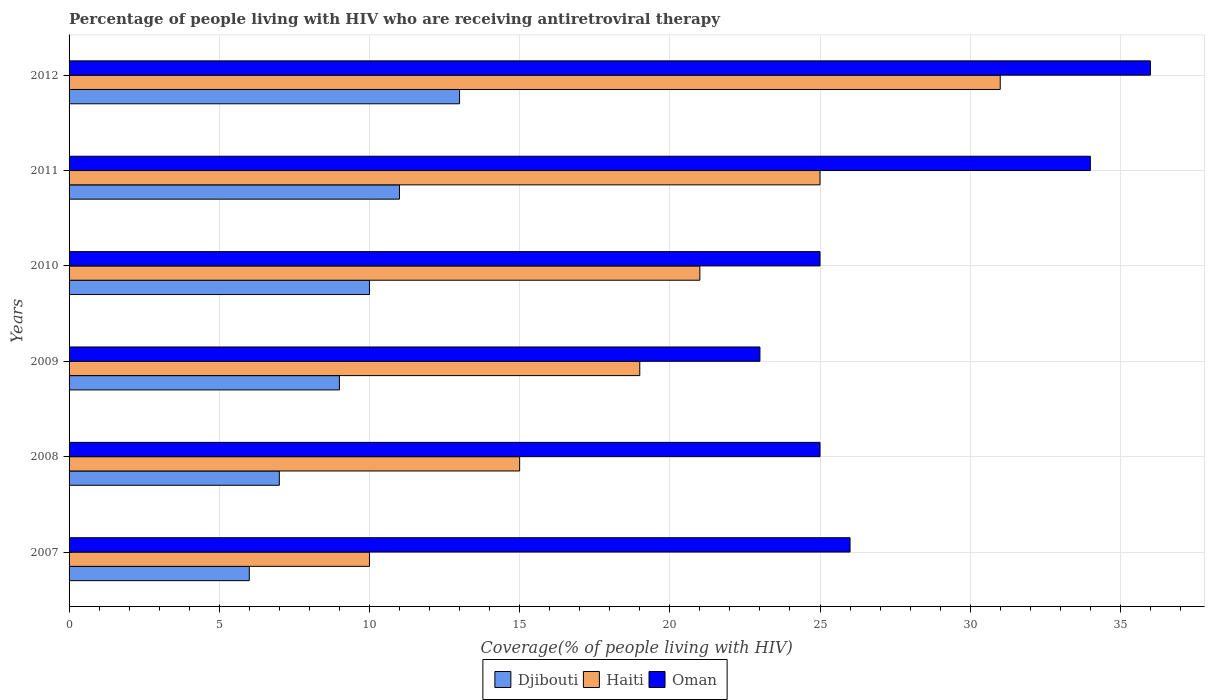How many different coloured bars are there?
Provide a short and direct response. 3. How many groups of bars are there?
Give a very brief answer. 6. Are the number of bars per tick equal to the number of legend labels?
Your answer should be compact. Yes. Are the number of bars on each tick of the Y-axis equal?
Your answer should be very brief. Yes. How many bars are there on the 6th tick from the top?
Your answer should be very brief. 3. How many bars are there on the 2nd tick from the bottom?
Ensure brevity in your answer.  3. What is the label of the 3rd group of bars from the top?
Keep it short and to the point. 2010. What is the percentage of the HIV infected people who are receiving antiretroviral therapy in Haiti in 2012?
Ensure brevity in your answer.  31. Across all years, what is the maximum percentage of the HIV infected people who are receiving antiretroviral therapy in Oman?
Give a very brief answer. 36. Across all years, what is the minimum percentage of the HIV infected people who are receiving antiretroviral therapy in Oman?
Your answer should be compact. 23. In which year was the percentage of the HIV infected people who are receiving antiretroviral therapy in Oman minimum?
Provide a short and direct response. 2009. What is the total percentage of the HIV infected people who are receiving antiretroviral therapy in Djibouti in the graph?
Your answer should be very brief. 56. What is the difference between the percentage of the HIV infected people who are receiving antiretroviral therapy in Djibouti in 2007 and that in 2009?
Give a very brief answer. -3. What is the difference between the percentage of the HIV infected people who are receiving antiretroviral therapy in Djibouti in 2009 and the percentage of the HIV infected people who are receiving antiretroviral therapy in Haiti in 2012?
Offer a terse response. -22. What is the average percentage of the HIV infected people who are receiving antiretroviral therapy in Haiti per year?
Provide a succinct answer. 20.17. In the year 2007, what is the difference between the percentage of the HIV infected people who are receiving antiretroviral therapy in Djibouti and percentage of the HIV infected people who are receiving antiretroviral therapy in Haiti?
Give a very brief answer. -4. In how many years, is the percentage of the HIV infected people who are receiving antiretroviral therapy in Haiti greater than 22 %?
Your answer should be very brief. 2. What is the ratio of the percentage of the HIV infected people who are receiving antiretroviral therapy in Oman in 2008 to that in 2009?
Provide a short and direct response. 1.09. Is the percentage of the HIV infected people who are receiving antiretroviral therapy in Djibouti in 2008 less than that in 2009?
Your answer should be very brief. Yes. What is the difference between the highest and the second highest percentage of the HIV infected people who are receiving antiretroviral therapy in Oman?
Keep it short and to the point. 2. What is the difference between the highest and the lowest percentage of the HIV infected people who are receiving antiretroviral therapy in Oman?
Provide a short and direct response. 13. What does the 3rd bar from the top in 2010 represents?
Your answer should be compact. Djibouti. What does the 3rd bar from the bottom in 2007 represents?
Give a very brief answer. Oman. How many bars are there?
Offer a very short reply. 18. Are all the bars in the graph horizontal?
Give a very brief answer. Yes. What is the difference between two consecutive major ticks on the X-axis?
Ensure brevity in your answer.  5. Are the values on the major ticks of X-axis written in scientific E-notation?
Offer a very short reply. No. What is the title of the graph?
Offer a terse response. Percentage of people living with HIV who are receiving antiretroviral therapy. Does "Seychelles" appear as one of the legend labels in the graph?
Offer a terse response. No. What is the label or title of the X-axis?
Make the answer very short. Coverage(% of people living with HIV). What is the label or title of the Y-axis?
Your answer should be compact. Years. What is the Coverage(% of people living with HIV) of Djibouti in 2007?
Your answer should be compact. 6. What is the Coverage(% of people living with HIV) of Oman in 2007?
Your response must be concise. 26. What is the Coverage(% of people living with HIV) in Oman in 2008?
Provide a succinct answer. 25. What is the Coverage(% of people living with HIV) of Djibouti in 2010?
Your answer should be compact. 10. What is the Coverage(% of people living with HIV) in Haiti in 2010?
Your answer should be compact. 21. What is the Coverage(% of people living with HIV) of Djibouti in 2011?
Ensure brevity in your answer.  11. What is the Coverage(% of people living with HIV) in Oman in 2011?
Offer a very short reply. 34. What is the Coverage(% of people living with HIV) in Djibouti in 2012?
Your answer should be very brief. 13. Across all years, what is the maximum Coverage(% of people living with HIV) in Djibouti?
Offer a terse response. 13. Across all years, what is the minimum Coverage(% of people living with HIV) of Haiti?
Give a very brief answer. 10. Across all years, what is the minimum Coverage(% of people living with HIV) in Oman?
Offer a very short reply. 23. What is the total Coverage(% of people living with HIV) of Djibouti in the graph?
Your answer should be very brief. 56. What is the total Coverage(% of people living with HIV) of Haiti in the graph?
Give a very brief answer. 121. What is the total Coverage(% of people living with HIV) in Oman in the graph?
Your response must be concise. 169. What is the difference between the Coverage(% of people living with HIV) of Djibouti in 2007 and that in 2009?
Make the answer very short. -3. What is the difference between the Coverage(% of people living with HIV) of Oman in 2007 and that in 2009?
Provide a short and direct response. 3. What is the difference between the Coverage(% of people living with HIV) in Djibouti in 2007 and that in 2010?
Keep it short and to the point. -4. What is the difference between the Coverage(% of people living with HIV) of Djibouti in 2007 and that in 2011?
Ensure brevity in your answer.  -5. What is the difference between the Coverage(% of people living with HIV) in Haiti in 2007 and that in 2011?
Provide a short and direct response. -15. What is the difference between the Coverage(% of people living with HIV) of Oman in 2007 and that in 2011?
Provide a short and direct response. -8. What is the difference between the Coverage(% of people living with HIV) in Oman in 2007 and that in 2012?
Your response must be concise. -10. What is the difference between the Coverage(% of people living with HIV) of Haiti in 2008 and that in 2009?
Ensure brevity in your answer.  -4. What is the difference between the Coverage(% of people living with HIV) in Haiti in 2008 and that in 2010?
Provide a short and direct response. -6. What is the difference between the Coverage(% of people living with HIV) in Oman in 2008 and that in 2010?
Ensure brevity in your answer.  0. What is the difference between the Coverage(% of people living with HIV) of Haiti in 2008 and that in 2011?
Offer a very short reply. -10. What is the difference between the Coverage(% of people living with HIV) in Oman in 2008 and that in 2011?
Make the answer very short. -9. What is the difference between the Coverage(% of people living with HIV) in Djibouti in 2008 and that in 2012?
Offer a terse response. -6. What is the difference between the Coverage(% of people living with HIV) of Haiti in 2008 and that in 2012?
Give a very brief answer. -16. What is the difference between the Coverage(% of people living with HIV) of Djibouti in 2009 and that in 2011?
Keep it short and to the point. -2. What is the difference between the Coverage(% of people living with HIV) of Haiti in 2009 and that in 2011?
Provide a succinct answer. -6. What is the difference between the Coverage(% of people living with HIV) of Oman in 2009 and that in 2011?
Keep it short and to the point. -11. What is the difference between the Coverage(% of people living with HIV) of Oman in 2009 and that in 2012?
Provide a short and direct response. -13. What is the difference between the Coverage(% of people living with HIV) of Djibouti in 2010 and that in 2011?
Offer a very short reply. -1. What is the difference between the Coverage(% of people living with HIV) in Djibouti in 2010 and that in 2012?
Provide a succinct answer. -3. What is the difference between the Coverage(% of people living with HIV) of Oman in 2010 and that in 2012?
Offer a terse response. -11. What is the difference between the Coverage(% of people living with HIV) in Oman in 2011 and that in 2012?
Provide a succinct answer. -2. What is the difference between the Coverage(% of people living with HIV) of Djibouti in 2007 and the Coverage(% of people living with HIV) of Haiti in 2008?
Your answer should be very brief. -9. What is the difference between the Coverage(% of people living with HIV) in Djibouti in 2007 and the Coverage(% of people living with HIV) in Haiti in 2009?
Offer a very short reply. -13. What is the difference between the Coverage(% of people living with HIV) of Djibouti in 2007 and the Coverage(% of people living with HIV) of Oman in 2009?
Give a very brief answer. -17. What is the difference between the Coverage(% of people living with HIV) in Haiti in 2007 and the Coverage(% of people living with HIV) in Oman in 2009?
Give a very brief answer. -13. What is the difference between the Coverage(% of people living with HIV) in Djibouti in 2007 and the Coverage(% of people living with HIV) in Oman in 2012?
Offer a terse response. -30. What is the difference between the Coverage(% of people living with HIV) in Djibouti in 2008 and the Coverage(% of people living with HIV) in Haiti in 2009?
Provide a short and direct response. -12. What is the difference between the Coverage(% of people living with HIV) in Djibouti in 2008 and the Coverage(% of people living with HIV) in Oman in 2009?
Ensure brevity in your answer.  -16. What is the difference between the Coverage(% of people living with HIV) of Djibouti in 2008 and the Coverage(% of people living with HIV) of Haiti in 2010?
Offer a terse response. -14. What is the difference between the Coverage(% of people living with HIV) of Djibouti in 2008 and the Coverage(% of people living with HIV) of Haiti in 2011?
Provide a short and direct response. -18. What is the difference between the Coverage(% of people living with HIV) of Haiti in 2008 and the Coverage(% of people living with HIV) of Oman in 2011?
Your answer should be very brief. -19. What is the difference between the Coverage(% of people living with HIV) in Djibouti in 2009 and the Coverage(% of people living with HIV) in Haiti in 2010?
Your answer should be very brief. -12. What is the difference between the Coverage(% of people living with HIV) in Djibouti in 2009 and the Coverage(% of people living with HIV) in Oman in 2010?
Your answer should be compact. -16. What is the difference between the Coverage(% of people living with HIV) of Haiti in 2009 and the Coverage(% of people living with HIV) of Oman in 2010?
Make the answer very short. -6. What is the difference between the Coverage(% of people living with HIV) in Djibouti in 2009 and the Coverage(% of people living with HIV) in Oman in 2011?
Keep it short and to the point. -25. What is the difference between the Coverage(% of people living with HIV) in Djibouti in 2009 and the Coverage(% of people living with HIV) in Haiti in 2012?
Make the answer very short. -22. What is the difference between the Coverage(% of people living with HIV) in Djibouti in 2009 and the Coverage(% of people living with HIV) in Oman in 2012?
Offer a very short reply. -27. What is the difference between the Coverage(% of people living with HIV) of Haiti in 2009 and the Coverage(% of people living with HIV) of Oman in 2012?
Provide a short and direct response. -17. What is the difference between the Coverage(% of people living with HIV) of Djibouti in 2010 and the Coverage(% of people living with HIV) of Haiti in 2011?
Provide a succinct answer. -15. What is the difference between the Coverage(% of people living with HIV) in Haiti in 2010 and the Coverage(% of people living with HIV) in Oman in 2011?
Your answer should be very brief. -13. What is the difference between the Coverage(% of people living with HIV) in Djibouti in 2010 and the Coverage(% of people living with HIV) in Haiti in 2012?
Offer a terse response. -21. What is the difference between the Coverage(% of people living with HIV) of Djibouti in 2010 and the Coverage(% of people living with HIV) of Oman in 2012?
Ensure brevity in your answer.  -26. What is the difference between the Coverage(% of people living with HIV) of Haiti in 2010 and the Coverage(% of people living with HIV) of Oman in 2012?
Ensure brevity in your answer.  -15. What is the difference between the Coverage(% of people living with HIV) in Haiti in 2011 and the Coverage(% of people living with HIV) in Oman in 2012?
Your response must be concise. -11. What is the average Coverage(% of people living with HIV) in Djibouti per year?
Make the answer very short. 9.33. What is the average Coverage(% of people living with HIV) of Haiti per year?
Ensure brevity in your answer.  20.17. What is the average Coverage(% of people living with HIV) in Oman per year?
Provide a succinct answer. 28.17. In the year 2007, what is the difference between the Coverage(% of people living with HIV) in Haiti and Coverage(% of people living with HIV) in Oman?
Your answer should be very brief. -16. In the year 2008, what is the difference between the Coverage(% of people living with HIV) in Djibouti and Coverage(% of people living with HIV) in Oman?
Offer a terse response. -18. In the year 2008, what is the difference between the Coverage(% of people living with HIV) of Haiti and Coverage(% of people living with HIV) of Oman?
Offer a terse response. -10. In the year 2010, what is the difference between the Coverage(% of people living with HIV) in Haiti and Coverage(% of people living with HIV) in Oman?
Offer a very short reply. -4. In the year 2011, what is the difference between the Coverage(% of people living with HIV) of Djibouti and Coverage(% of people living with HIV) of Haiti?
Provide a succinct answer. -14. In the year 2011, what is the difference between the Coverage(% of people living with HIV) in Djibouti and Coverage(% of people living with HIV) in Oman?
Provide a short and direct response. -23. In the year 2011, what is the difference between the Coverage(% of people living with HIV) in Haiti and Coverage(% of people living with HIV) in Oman?
Offer a terse response. -9. In the year 2012, what is the difference between the Coverage(% of people living with HIV) of Djibouti and Coverage(% of people living with HIV) of Haiti?
Ensure brevity in your answer.  -18. In the year 2012, what is the difference between the Coverage(% of people living with HIV) in Haiti and Coverage(% of people living with HIV) in Oman?
Provide a succinct answer. -5. What is the ratio of the Coverage(% of people living with HIV) in Djibouti in 2007 to that in 2008?
Your response must be concise. 0.86. What is the ratio of the Coverage(% of people living with HIV) of Haiti in 2007 to that in 2008?
Offer a terse response. 0.67. What is the ratio of the Coverage(% of people living with HIV) in Oman in 2007 to that in 2008?
Your answer should be compact. 1.04. What is the ratio of the Coverage(% of people living with HIV) in Haiti in 2007 to that in 2009?
Your answer should be very brief. 0.53. What is the ratio of the Coverage(% of people living with HIV) of Oman in 2007 to that in 2009?
Offer a terse response. 1.13. What is the ratio of the Coverage(% of people living with HIV) of Djibouti in 2007 to that in 2010?
Your answer should be compact. 0.6. What is the ratio of the Coverage(% of people living with HIV) of Haiti in 2007 to that in 2010?
Make the answer very short. 0.48. What is the ratio of the Coverage(% of people living with HIV) of Oman in 2007 to that in 2010?
Make the answer very short. 1.04. What is the ratio of the Coverage(% of people living with HIV) in Djibouti in 2007 to that in 2011?
Give a very brief answer. 0.55. What is the ratio of the Coverage(% of people living with HIV) of Haiti in 2007 to that in 2011?
Your answer should be very brief. 0.4. What is the ratio of the Coverage(% of people living with HIV) of Oman in 2007 to that in 2011?
Your answer should be very brief. 0.76. What is the ratio of the Coverage(% of people living with HIV) in Djibouti in 2007 to that in 2012?
Your answer should be very brief. 0.46. What is the ratio of the Coverage(% of people living with HIV) of Haiti in 2007 to that in 2012?
Provide a short and direct response. 0.32. What is the ratio of the Coverage(% of people living with HIV) of Oman in 2007 to that in 2012?
Make the answer very short. 0.72. What is the ratio of the Coverage(% of people living with HIV) in Haiti in 2008 to that in 2009?
Provide a succinct answer. 0.79. What is the ratio of the Coverage(% of people living with HIV) of Oman in 2008 to that in 2009?
Your response must be concise. 1.09. What is the ratio of the Coverage(% of people living with HIV) of Haiti in 2008 to that in 2010?
Provide a succinct answer. 0.71. What is the ratio of the Coverage(% of people living with HIV) of Djibouti in 2008 to that in 2011?
Make the answer very short. 0.64. What is the ratio of the Coverage(% of people living with HIV) of Haiti in 2008 to that in 2011?
Your response must be concise. 0.6. What is the ratio of the Coverage(% of people living with HIV) in Oman in 2008 to that in 2011?
Offer a terse response. 0.74. What is the ratio of the Coverage(% of people living with HIV) of Djibouti in 2008 to that in 2012?
Your response must be concise. 0.54. What is the ratio of the Coverage(% of people living with HIV) of Haiti in 2008 to that in 2012?
Offer a terse response. 0.48. What is the ratio of the Coverage(% of people living with HIV) in Oman in 2008 to that in 2012?
Provide a succinct answer. 0.69. What is the ratio of the Coverage(% of people living with HIV) of Haiti in 2009 to that in 2010?
Make the answer very short. 0.9. What is the ratio of the Coverage(% of people living with HIV) of Djibouti in 2009 to that in 2011?
Make the answer very short. 0.82. What is the ratio of the Coverage(% of people living with HIV) in Haiti in 2009 to that in 2011?
Provide a succinct answer. 0.76. What is the ratio of the Coverage(% of people living with HIV) of Oman in 2009 to that in 2011?
Your answer should be compact. 0.68. What is the ratio of the Coverage(% of people living with HIV) of Djibouti in 2009 to that in 2012?
Your answer should be compact. 0.69. What is the ratio of the Coverage(% of people living with HIV) in Haiti in 2009 to that in 2012?
Make the answer very short. 0.61. What is the ratio of the Coverage(% of people living with HIV) in Oman in 2009 to that in 2012?
Offer a very short reply. 0.64. What is the ratio of the Coverage(% of people living with HIV) in Haiti in 2010 to that in 2011?
Ensure brevity in your answer.  0.84. What is the ratio of the Coverage(% of people living with HIV) in Oman in 2010 to that in 2011?
Your answer should be very brief. 0.74. What is the ratio of the Coverage(% of people living with HIV) of Djibouti in 2010 to that in 2012?
Your answer should be compact. 0.77. What is the ratio of the Coverage(% of people living with HIV) of Haiti in 2010 to that in 2012?
Provide a short and direct response. 0.68. What is the ratio of the Coverage(% of people living with HIV) in Oman in 2010 to that in 2012?
Ensure brevity in your answer.  0.69. What is the ratio of the Coverage(% of people living with HIV) in Djibouti in 2011 to that in 2012?
Provide a succinct answer. 0.85. What is the ratio of the Coverage(% of people living with HIV) of Haiti in 2011 to that in 2012?
Provide a succinct answer. 0.81. What is the ratio of the Coverage(% of people living with HIV) of Oman in 2011 to that in 2012?
Make the answer very short. 0.94. What is the difference between the highest and the second highest Coverage(% of people living with HIV) in Djibouti?
Give a very brief answer. 2. What is the difference between the highest and the lowest Coverage(% of people living with HIV) of Oman?
Provide a short and direct response. 13. 